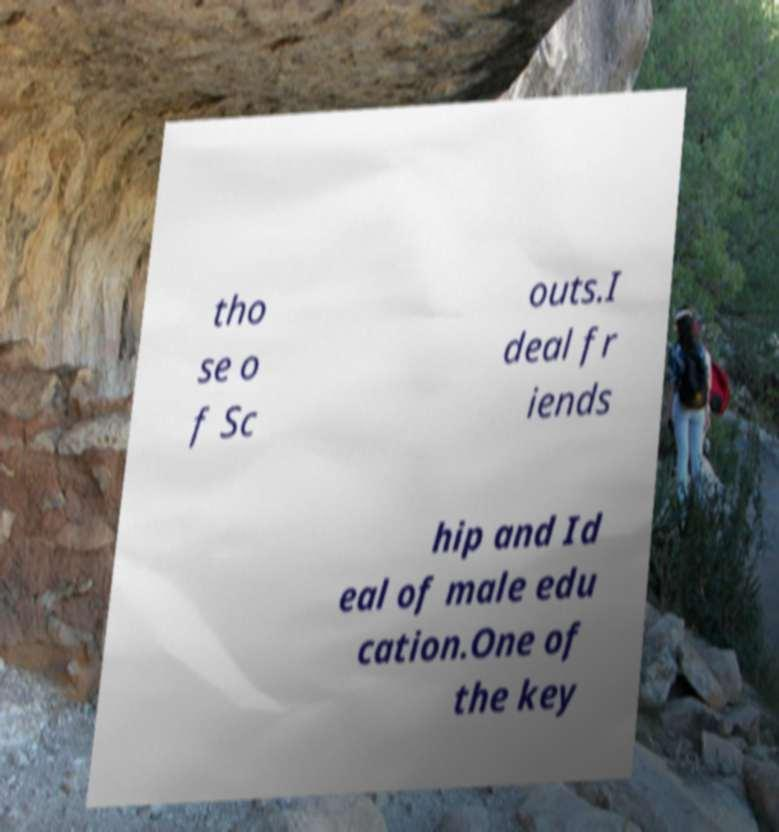Can you read and provide the text displayed in the image?This photo seems to have some interesting text. Can you extract and type it out for me? tho se o f Sc outs.I deal fr iends hip and Id eal of male edu cation.One of the key 